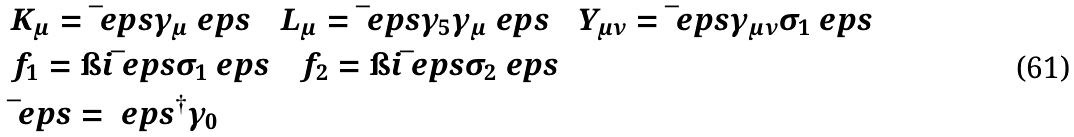<formula> <loc_0><loc_0><loc_500><loc_500>& K _ { \mu } = \bar { \ } e p s \gamma _ { \mu } \ e p s \quad L _ { \mu } = \bar { \ } e p s \gamma _ { 5 } \gamma _ { \mu } \ e p s \quad Y _ { \mu \nu } = \bar { \ } e p s \gamma _ { \mu \nu } \sigma _ { 1 } \ e p s \\ & f _ { 1 } = \i i \bar { \ } e p s \sigma _ { 1 } \ e p s \quad f _ { 2 } = \i i \bar { \ } e p s \sigma _ { 2 } \ e p s \\ & \bar { \ } e p s = \ e p s ^ { \dag } \gamma _ { 0 }</formula> 